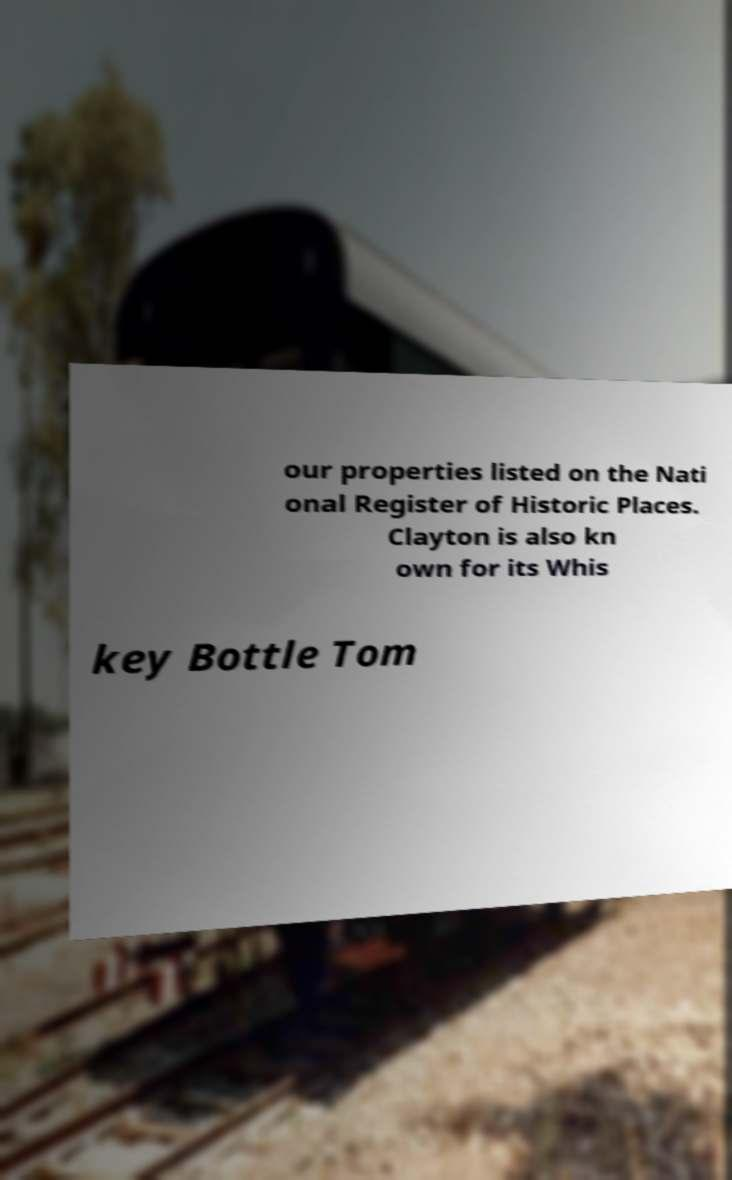I need the written content from this picture converted into text. Can you do that? our properties listed on the Nati onal Register of Historic Places. Clayton is also kn own for its Whis key Bottle Tom 